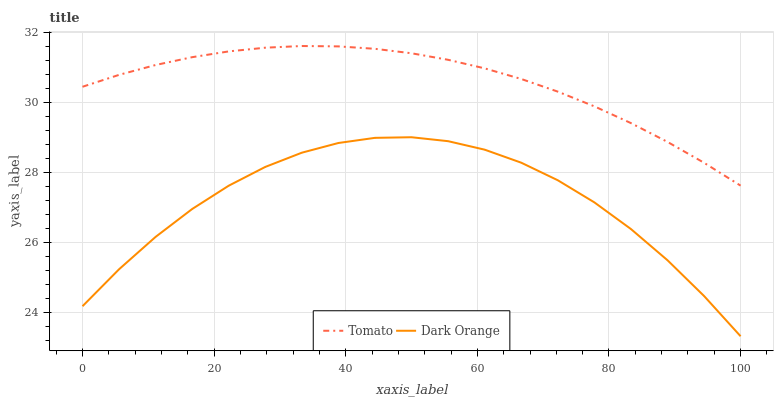Does Dark Orange have the minimum area under the curve?
Answer yes or no. Yes. Does Tomato have the maximum area under the curve?
Answer yes or no. Yes. Does Dark Orange have the maximum area under the curve?
Answer yes or no. No. Is Tomato the smoothest?
Answer yes or no. Yes. Is Dark Orange the roughest?
Answer yes or no. Yes. Is Dark Orange the smoothest?
Answer yes or no. No. Does Dark Orange have the lowest value?
Answer yes or no. Yes. Does Tomato have the highest value?
Answer yes or no. Yes. Does Dark Orange have the highest value?
Answer yes or no. No. Is Dark Orange less than Tomato?
Answer yes or no. Yes. Is Tomato greater than Dark Orange?
Answer yes or no. Yes. Does Dark Orange intersect Tomato?
Answer yes or no. No. 